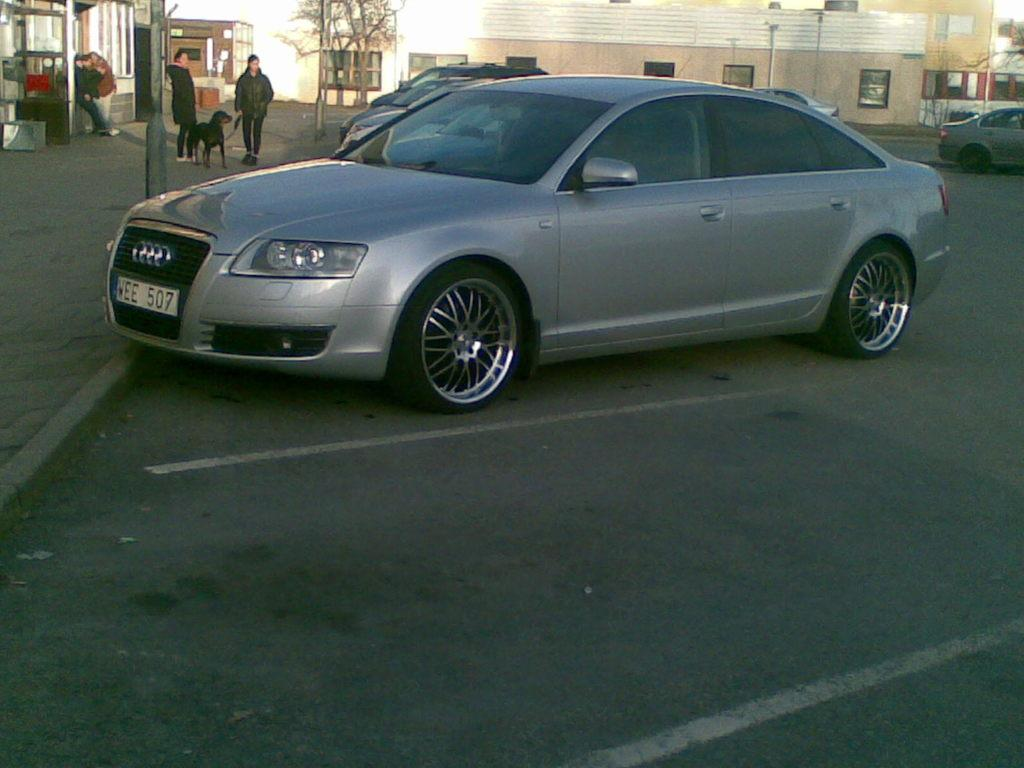What type of vehicles can be seen in the image? There are cars in the image. How many people are visible in the image? There are two people standing in the image. What animal is present on the road in the image? There is a dog on the road in the image. What can be seen in the background of the image? There are buildings with windows, trees, a footpath, and some people in the background of the image. What other objects can be seen in the background of the image? There are some objects in the background of the image. What color is the pen that the dog is holding in the image? There is no pen present in the image, and the dog is not holding anything. What type of metal is the silver statue in the image made of? There is no statue, silver, or any other metal object mentioned in the provided facts. 